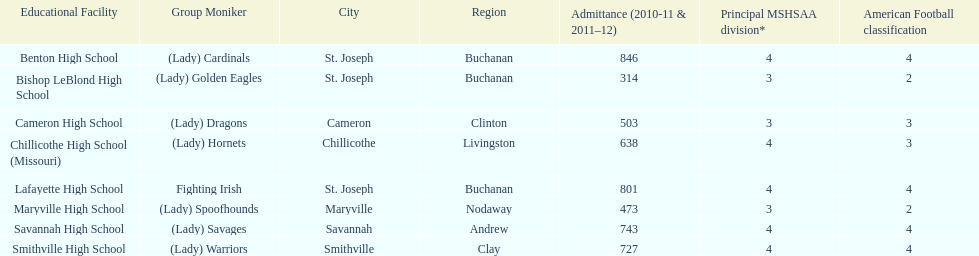How many of the schools had at least 500 students enrolled in the 2010-2011 and 2011-2012 season? 6. 